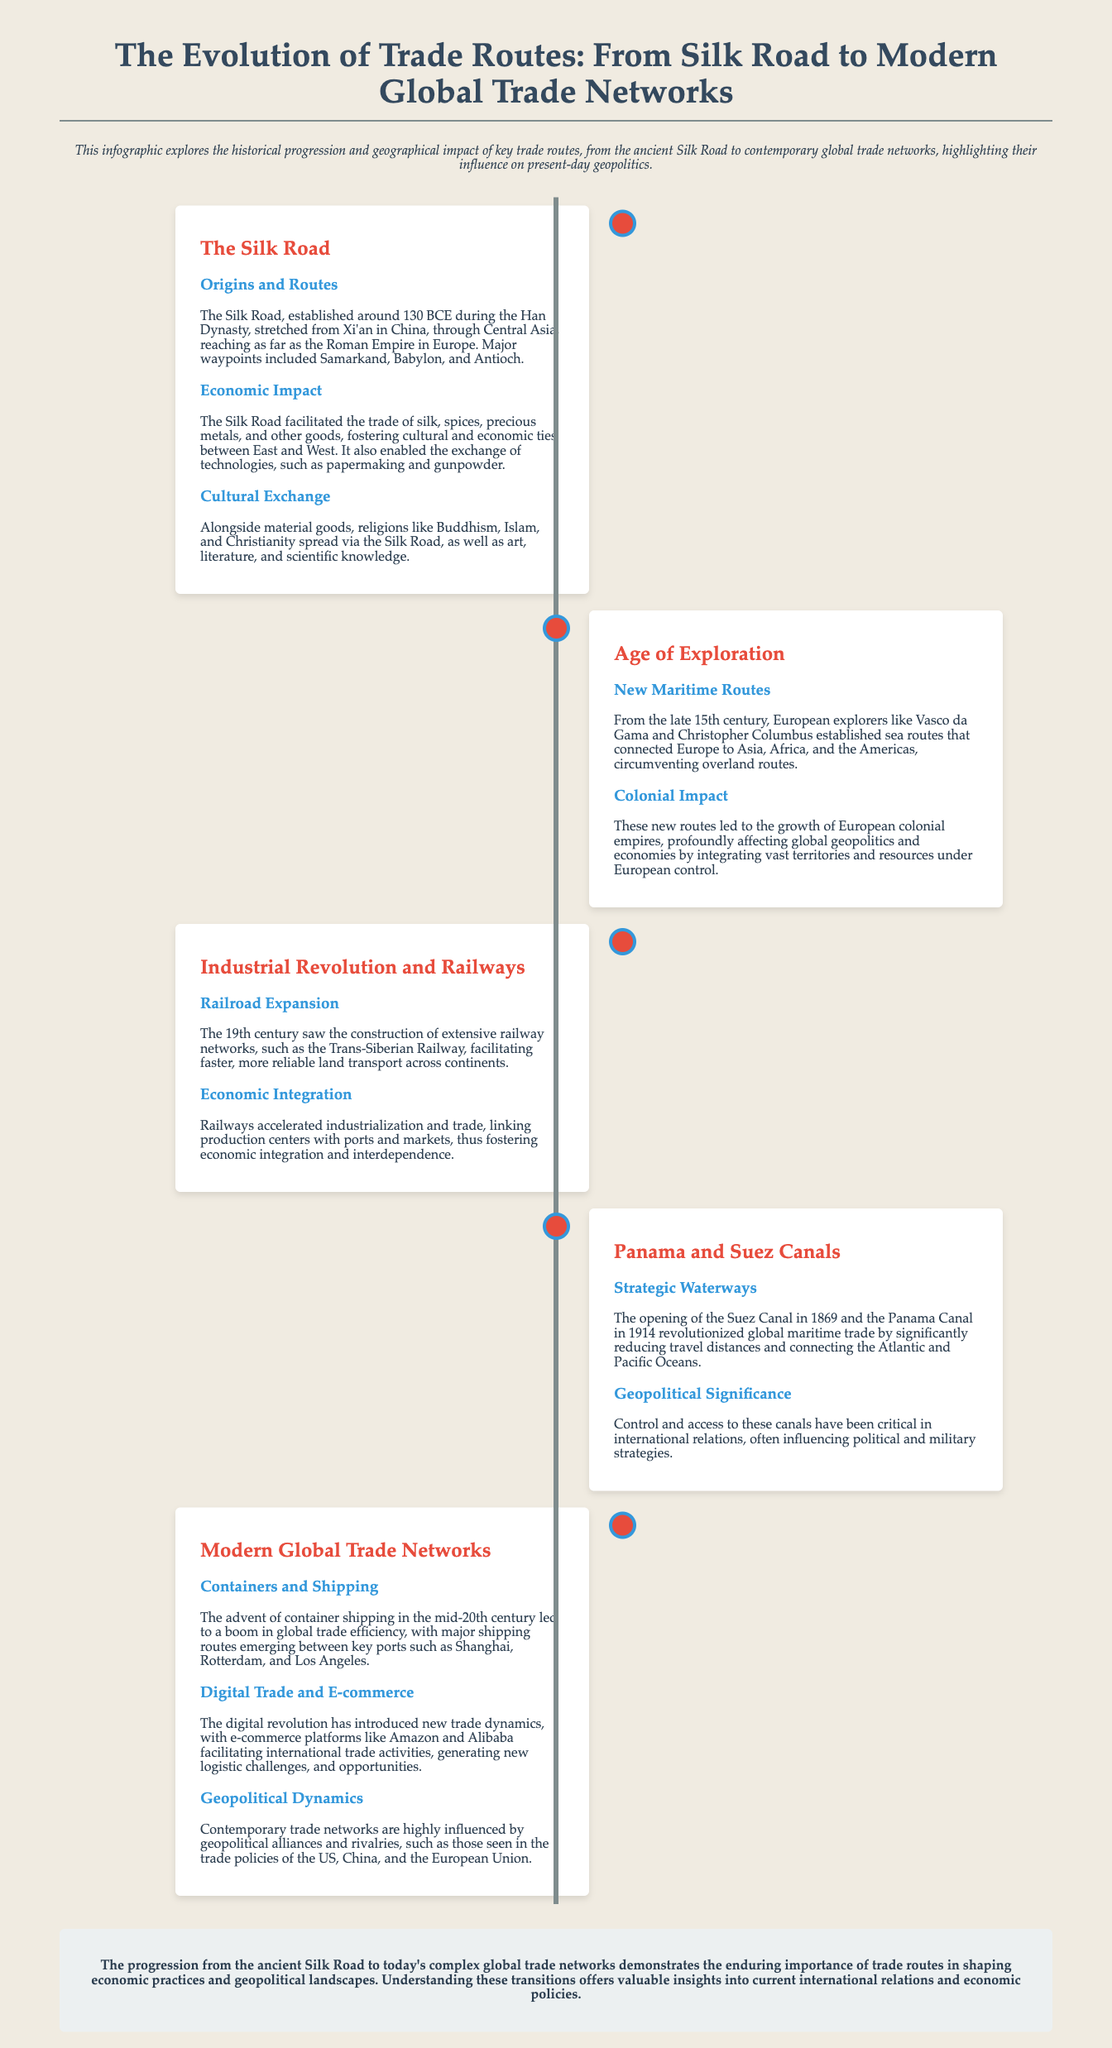What year did the Silk Road originate? The Silk Road was established around 130 BCE during the Han Dynasty.
Answer: 130 BCE What major waterway opened in 1869? The Suez Canal opened in 1869, revolutionizing global maritime trade.
Answer: Suez Canal Who were key figures of the Age of Exploration? European explorers like Vasco da Gama and Christopher Columbus established new maritime routes.
Answer: Vasco da Gama and Christopher Columbus What significant impact did the Industrial Revolution have on trade? Railways accelerated industrialization and trade, linking production centers with ports and markets.
Answer: Economic Integration What is a major shipping route developed in the mid-20th century? The advent of container shipping led to a boom in global trade efficiency with routes emerging between key ports.
Answer: Container shipping What influenced contemporary trade networks? Contemporary trade networks are highly influenced by geopolitical alliances and rivalries.
Answer: Geopolitical alliances and rivalries Which religions spread via the Silk Road? Alongside material goods, religions like Buddhism, Islam, and Christianity spread via the Silk Road.
Answer: Buddhism, Islam, and Christianity What infrastructure revolutionized global maritime trade? The opening of the Suez and Panama Canals revolutionized global maritime trade by significantly reducing travel distances.
Answer: Suez and Panama Canals 